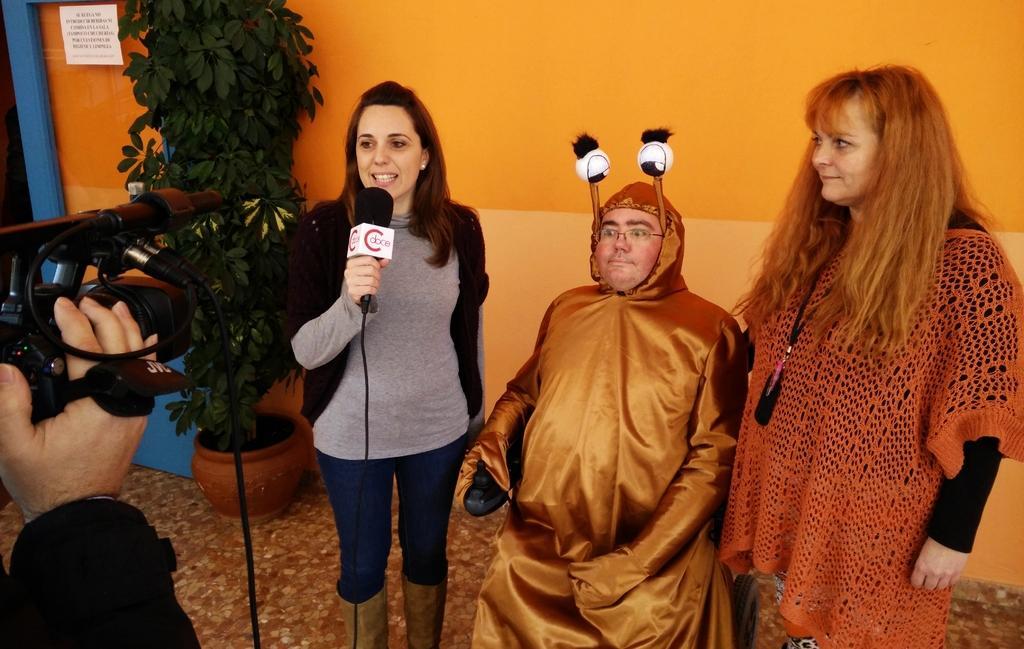Describe this image in one or two sentences. There is a woman holding a mic and speaking in front of it and there is a person sitting beside her is wearing a fancy dress and there is another woman in the right corner and there is a person holding a camera in the left corner. 